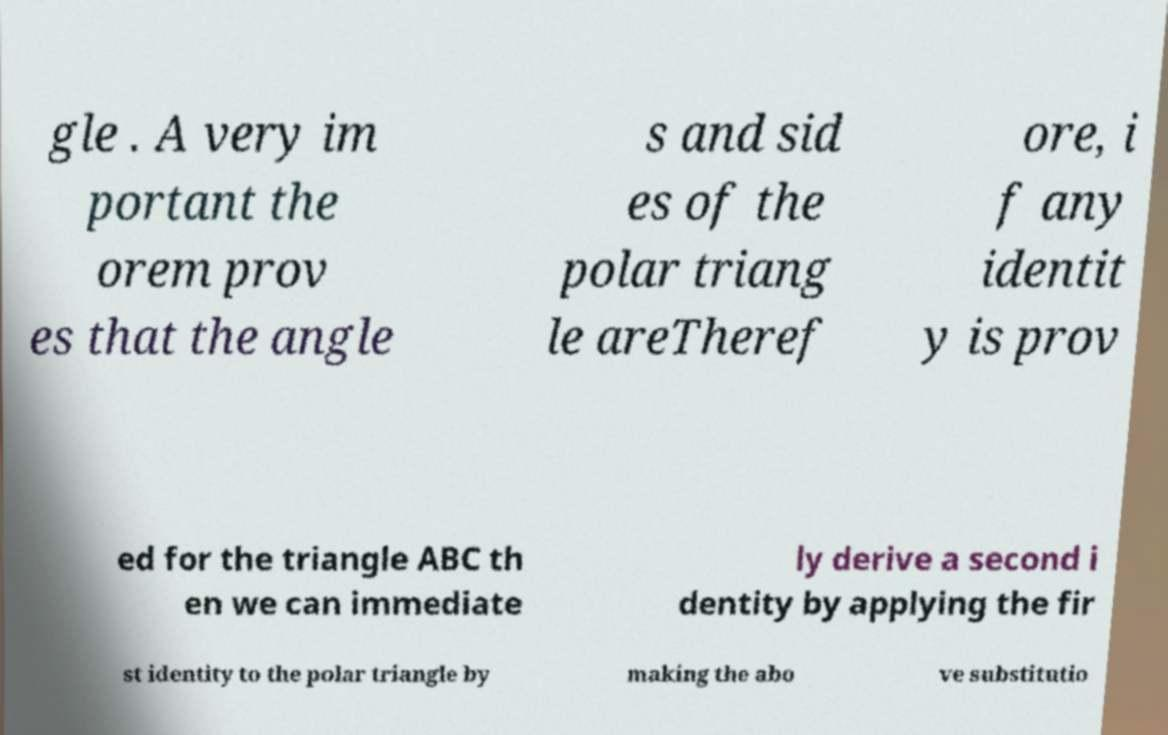Could you extract and type out the text from this image? gle . A very im portant the orem prov es that the angle s and sid es of the polar triang le areTheref ore, i f any identit y is prov ed for the triangle ABC th en we can immediate ly derive a second i dentity by applying the fir st identity to the polar triangle by making the abo ve substitutio 